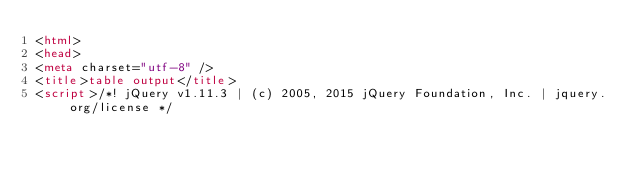<code> <loc_0><loc_0><loc_500><loc_500><_HTML_><html>
<head>
<meta charset="utf-8" />
<title>table output</title>
<script>/*! jQuery v1.11.3 | (c) 2005, 2015 jQuery Foundation, Inc. | jquery.org/license */</code> 